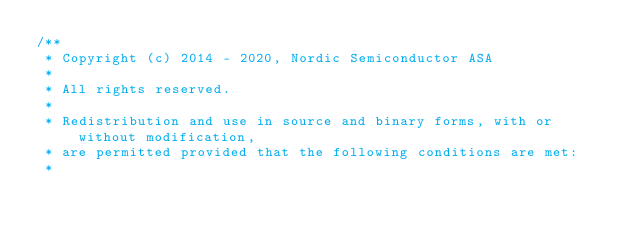<code> <loc_0><loc_0><loc_500><loc_500><_C_>/**
 * Copyright (c) 2014 - 2020, Nordic Semiconductor ASA
 *
 * All rights reserved.
 *
 * Redistribution and use in source and binary forms, with or without modification,
 * are permitted provided that the following conditions are met:
 *</code> 